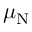<formula> <loc_0><loc_0><loc_500><loc_500>\mu _ { N }</formula> 